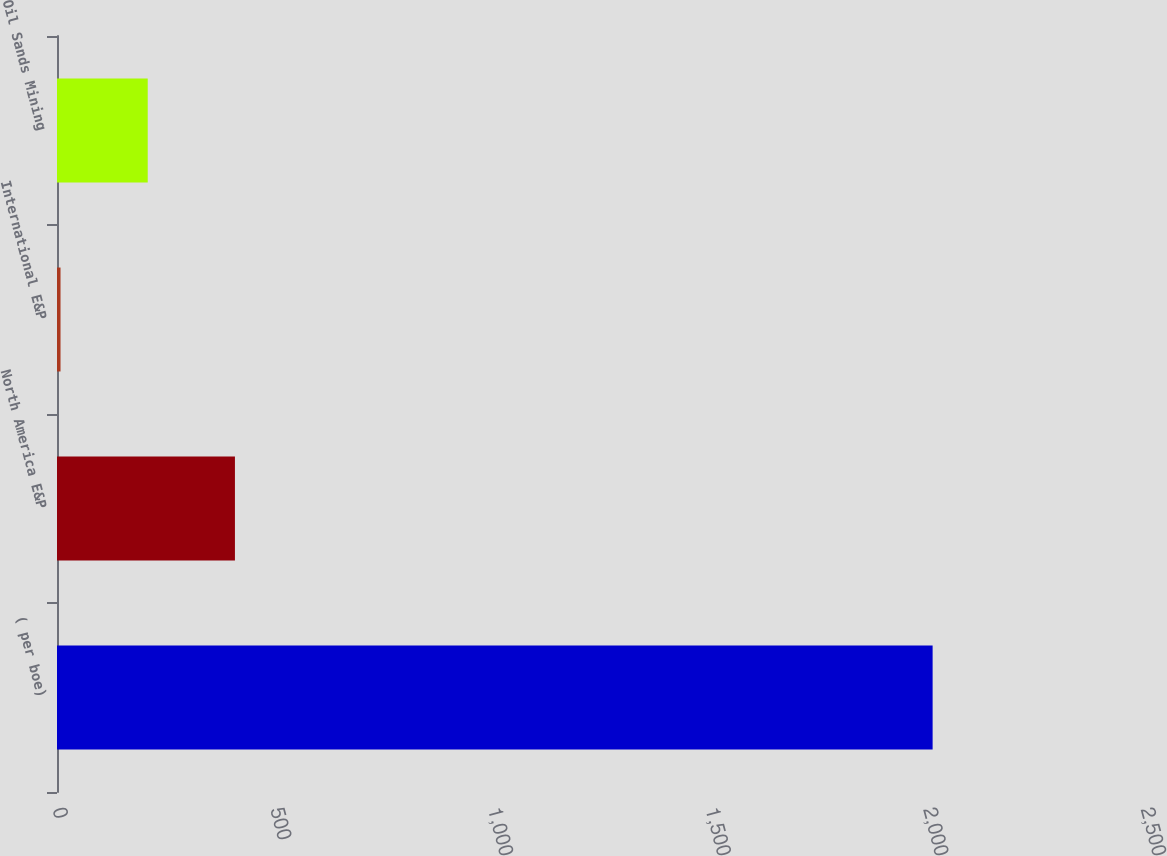Convert chart to OTSL. <chart><loc_0><loc_0><loc_500><loc_500><bar_chart><fcel>( per boe)<fcel>North America E&P<fcel>International E&P<fcel>Oil Sands Mining<nl><fcel>2012<fcel>408.86<fcel>8.08<fcel>208.47<nl></chart> 